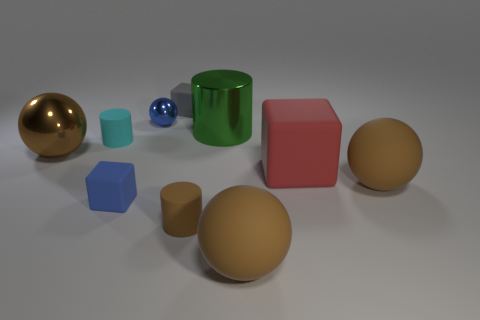Subtract all red cylinders. How many brown balls are left? 3 Subtract all cyan balls. Subtract all cyan cubes. How many balls are left? 4 Subtract all cubes. How many objects are left? 7 Subtract 1 gray blocks. How many objects are left? 9 Subtract all large shiny cylinders. Subtract all large shiny cylinders. How many objects are left? 8 Add 3 big blocks. How many big blocks are left? 4 Add 1 large red cubes. How many large red cubes exist? 2 